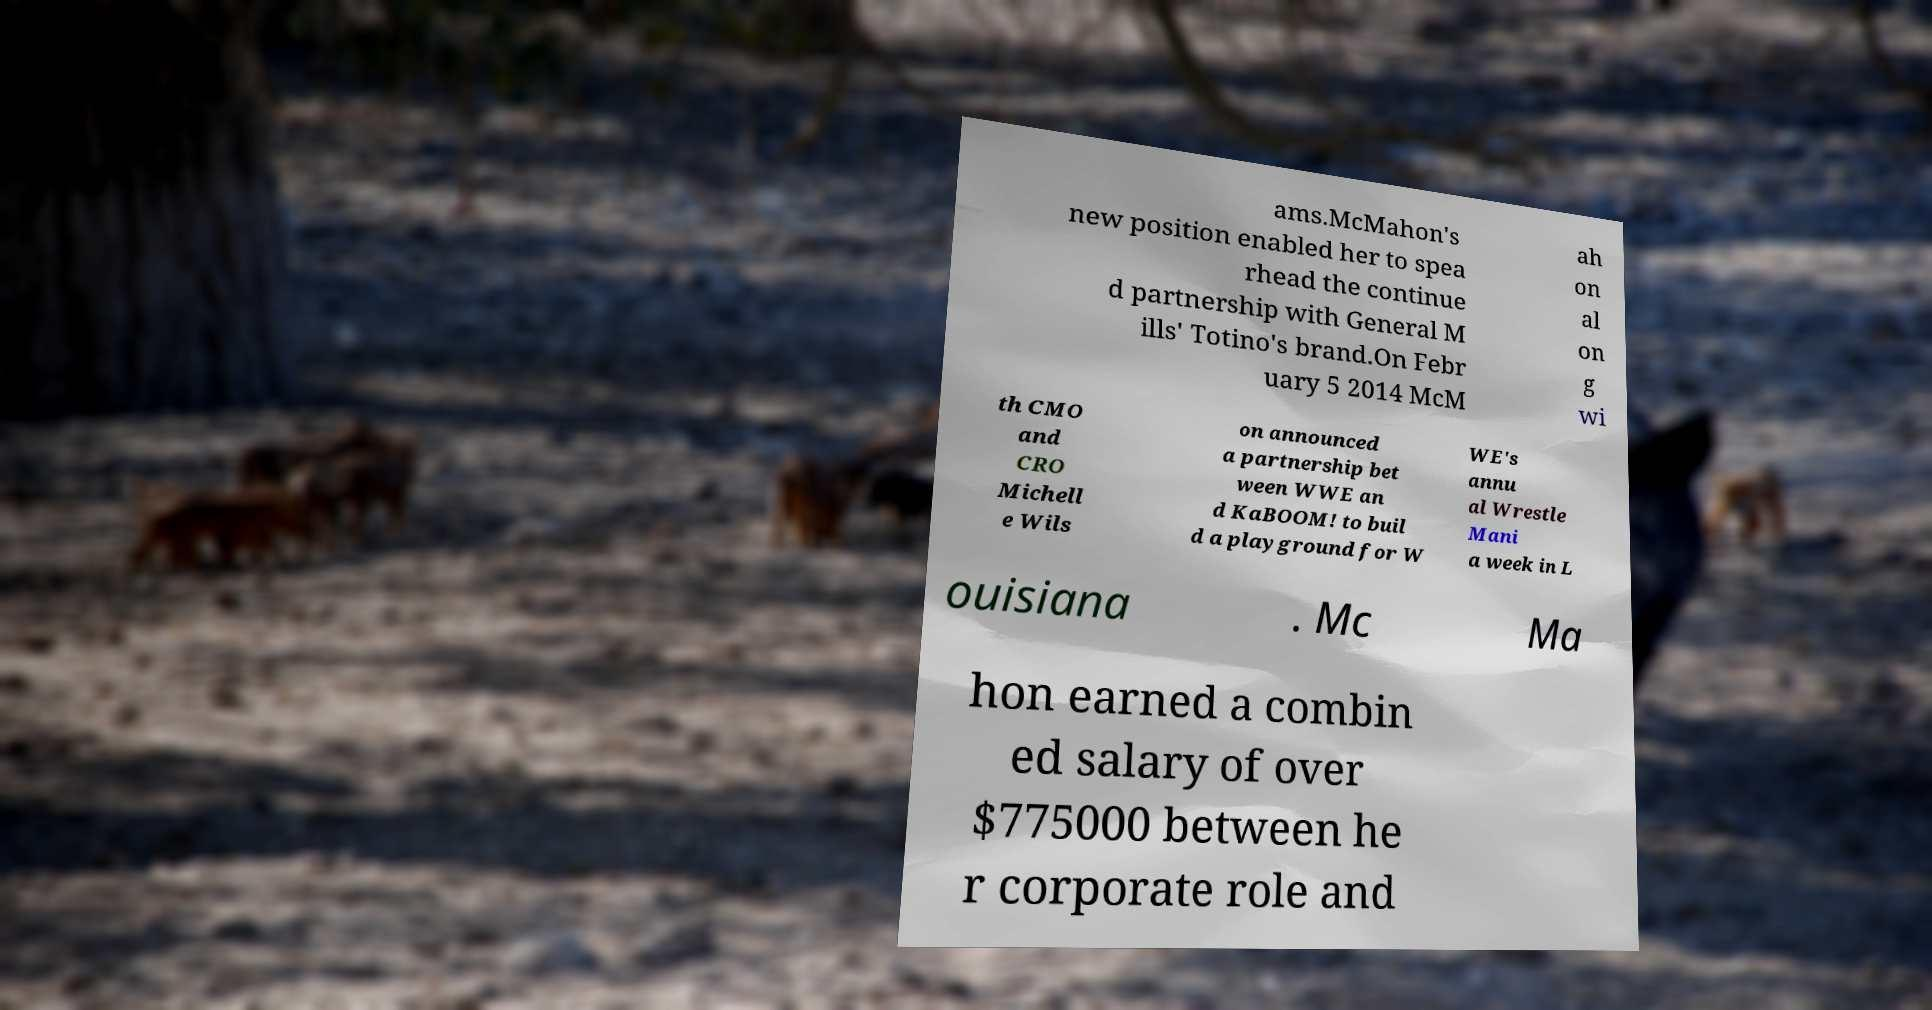Please identify and transcribe the text found in this image. ams.McMahon's new position enabled her to spea rhead the continue d partnership with General M ills' Totino's brand.On Febr uary 5 2014 McM ah on al on g wi th CMO and CRO Michell e Wils on announced a partnership bet ween WWE an d KaBOOM! to buil d a playground for W WE's annu al Wrestle Mani a week in L ouisiana . Mc Ma hon earned a combin ed salary of over $775000 between he r corporate role and 